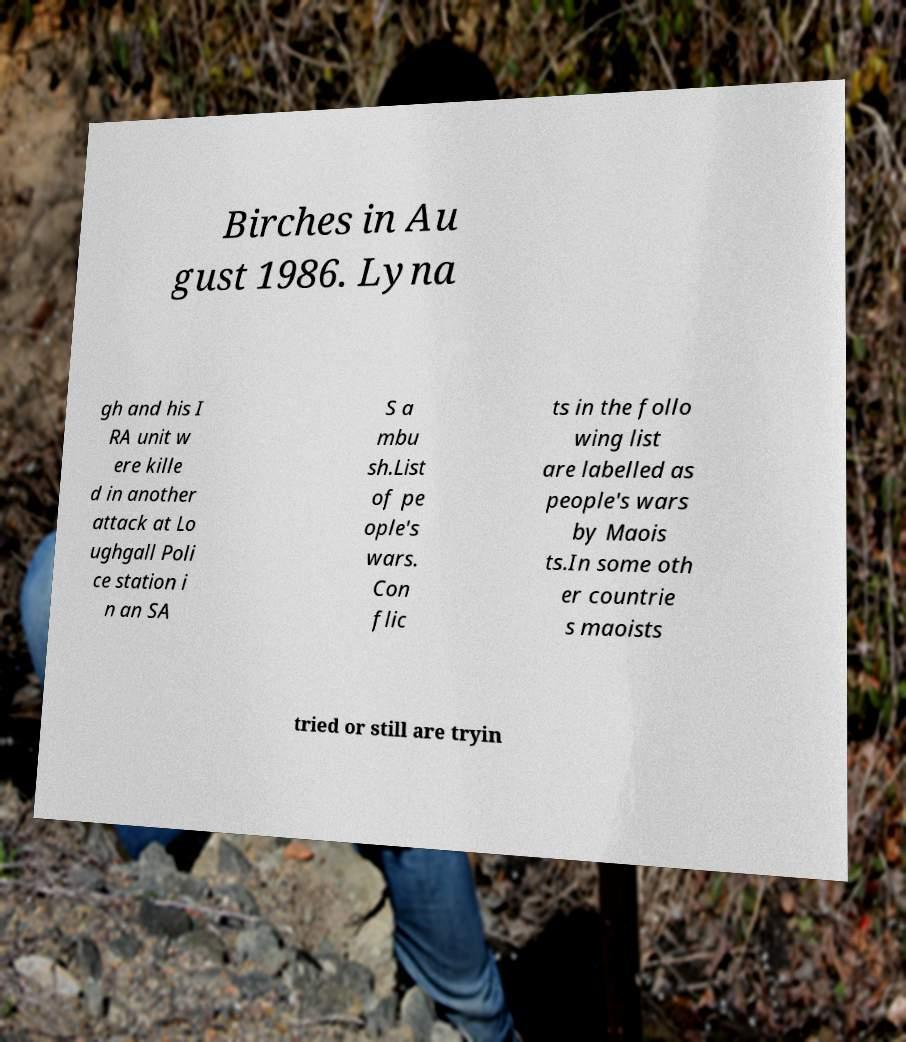Can you read and provide the text displayed in the image?This photo seems to have some interesting text. Can you extract and type it out for me? Birches in Au gust 1986. Lyna gh and his I RA unit w ere kille d in another attack at Lo ughgall Poli ce station i n an SA S a mbu sh.List of pe ople's wars. Con flic ts in the follo wing list are labelled as people's wars by Maois ts.In some oth er countrie s maoists tried or still are tryin 